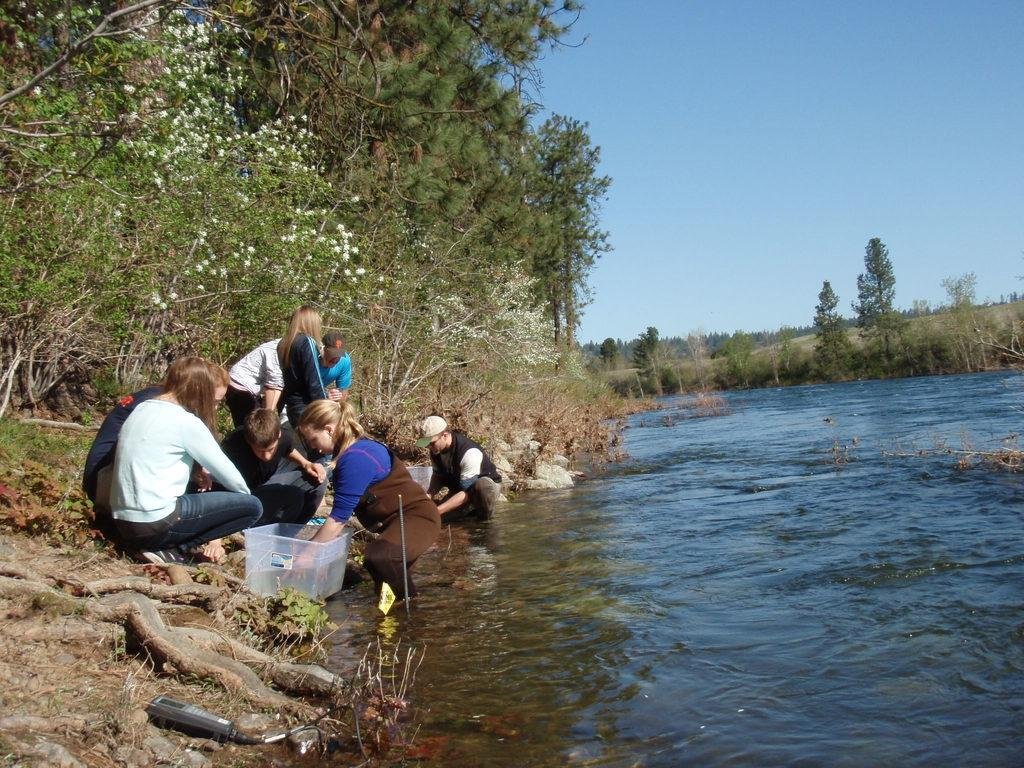How many people are in the image? There are people in the image, but the exact number is not specified. What is the container used for in the image? The purpose of the container is not clear from the facts provided. What is the water visible in the image being used for? The purpose of the water is not specified in the facts provided. What type of vegetation is visible in the background of the image? There are plants and trees visible in the background of the image. What is visible in the sky in the background of the image? The sky is visible in the background of the image. How many dimes are hidden in the plants in the image? There is no mention of dimes in the image, so it is not possible to determine how many might be hidden in the plants. 